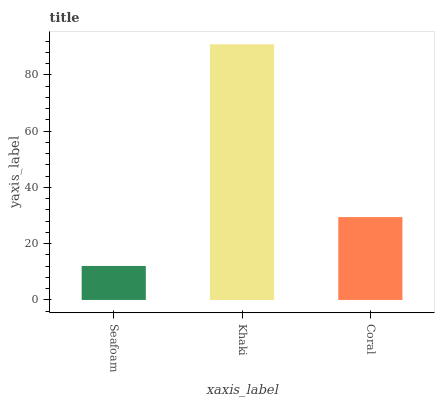Is Seafoam the minimum?
Answer yes or no. Yes. Is Khaki the maximum?
Answer yes or no. Yes. Is Coral the minimum?
Answer yes or no. No. Is Coral the maximum?
Answer yes or no. No. Is Khaki greater than Coral?
Answer yes or no. Yes. Is Coral less than Khaki?
Answer yes or no. Yes. Is Coral greater than Khaki?
Answer yes or no. No. Is Khaki less than Coral?
Answer yes or no. No. Is Coral the high median?
Answer yes or no. Yes. Is Coral the low median?
Answer yes or no. Yes. Is Khaki the high median?
Answer yes or no. No. Is Seafoam the low median?
Answer yes or no. No. 